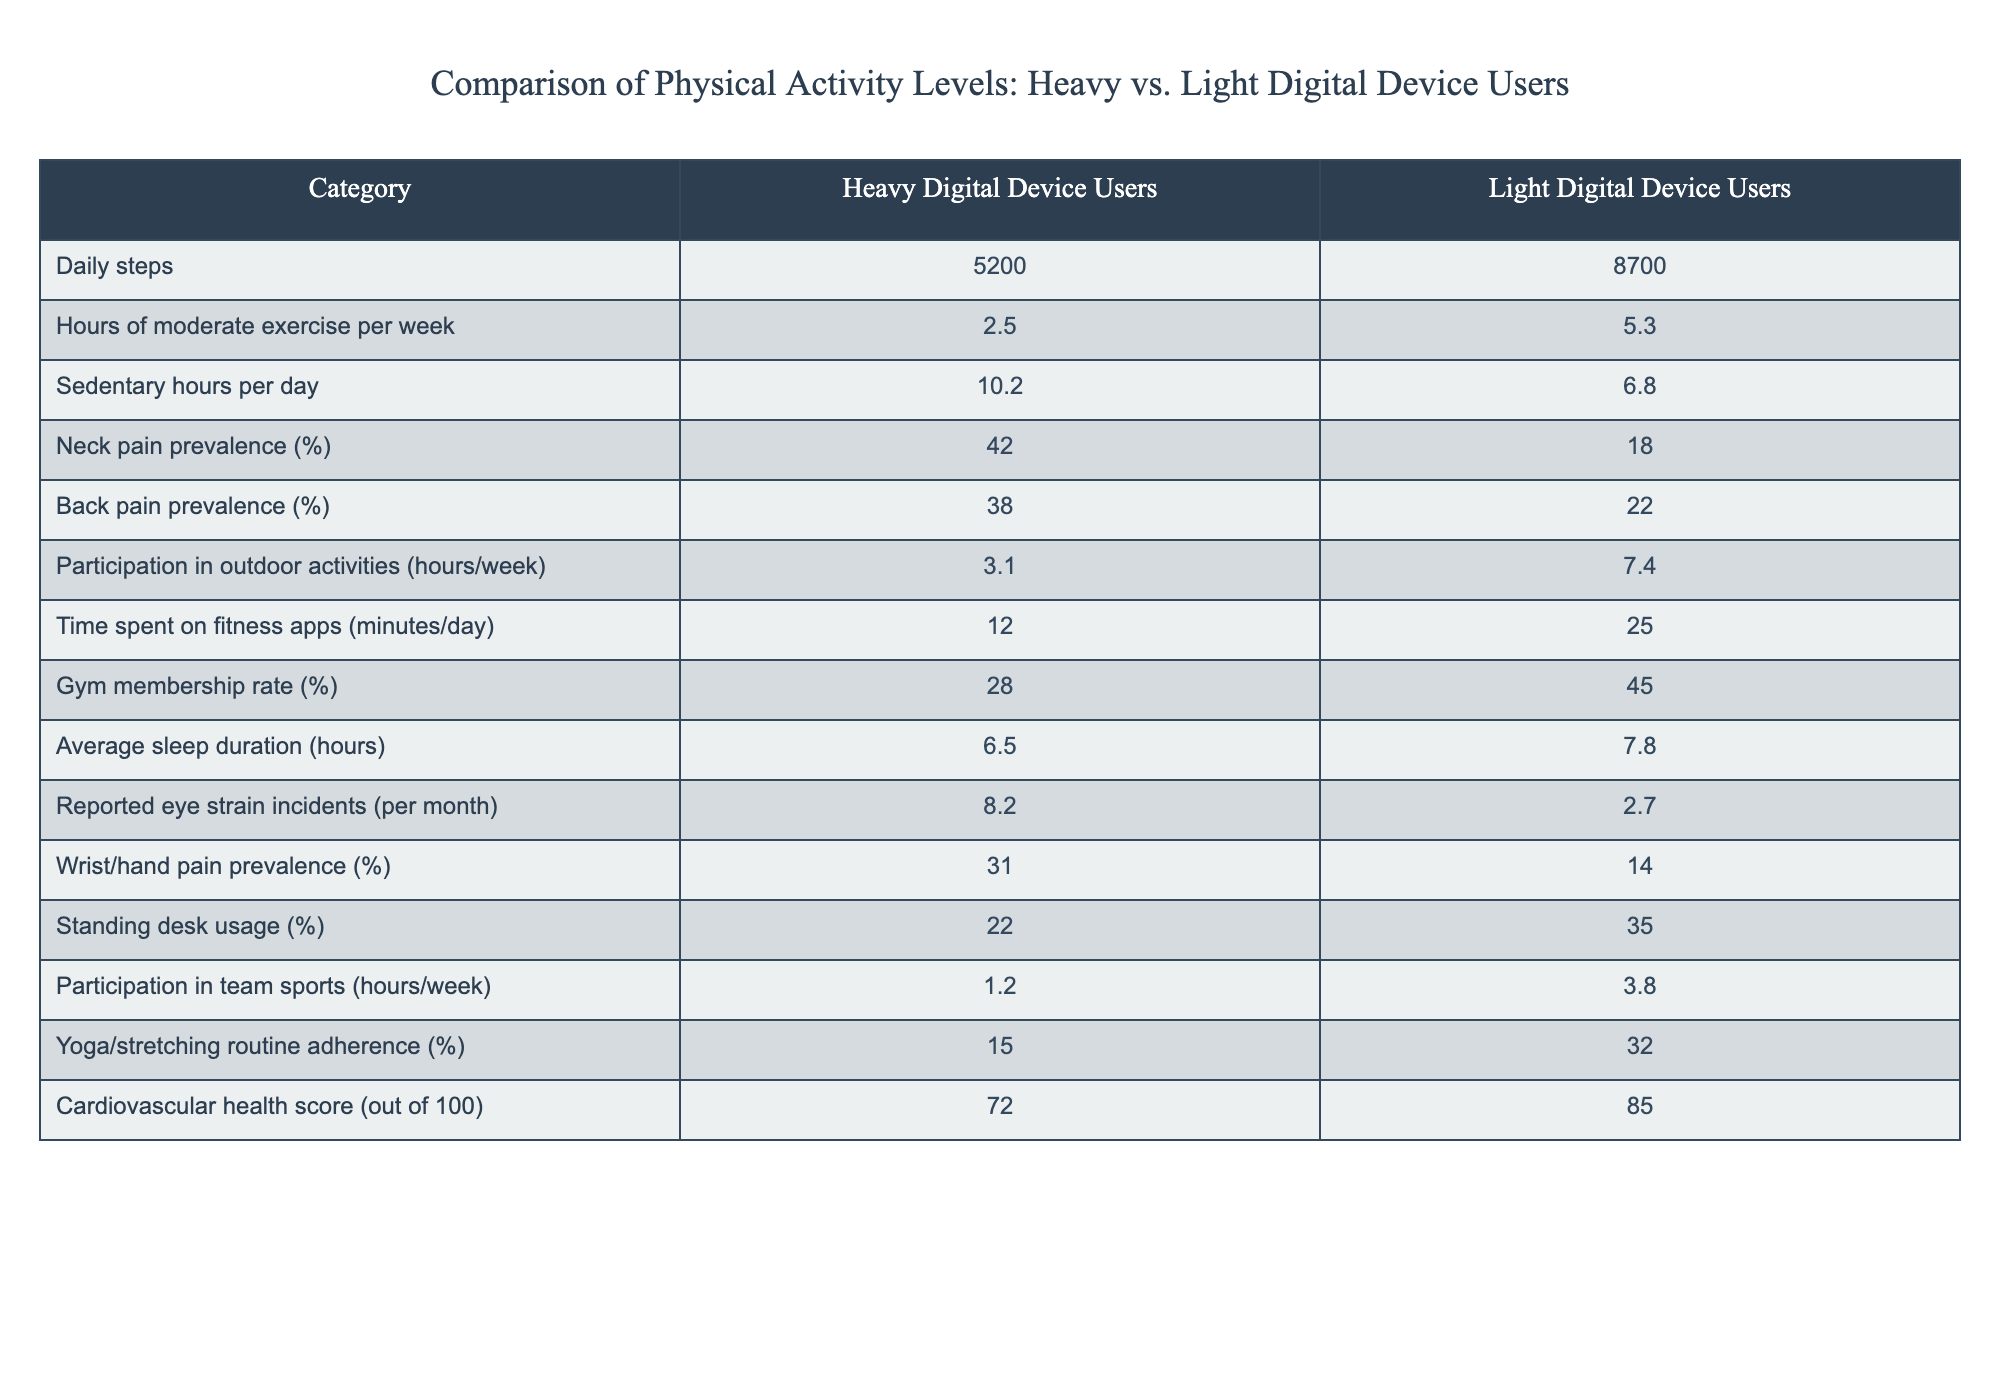What is the average daily steps for heavy digital device users? The table shows that heavy digital device users take 5200 steps per day. Since there is only one data point for heavy users, this is the average.
Answer: 5200 What is the percentage of neck pain prevalence among light digital device users? Referring to the table, the neck pain prevalence for light digital device users is stated as 18%.
Answer: 18% What is the difference in average daily steps between heavy and light digital device users? Heavy digital device users take 5200 steps daily, while light users take 8700 steps. The difference is calculated as 8700 - 5200 = 3500.
Answer: 3500 Is the prevalence of back pain higher among heavy digital device users compared to light users? The prevalence for heavy digital device users is 38%, while for light users it is 22%. Since 38% is greater than 22%, the statement is true.
Answer: Yes What percentage of light digital device users participate in a yoga/stretching routine? According to the table, 32% of light digital device users adhere to a yoga/stretching routine.
Answer: 32% How many more hours of moderate exercise are performed by light digital device users compared to heavy users per week? Light digital device users have 5.3 hours of moderate exercise per week, while heavy users have 2.5 hours. The difference is 5.3 - 2.5 = 2.8 hours.
Answer: 2.8 hours What is the average sleep duration difference between heavy and light digital device users? The average sleep duration for heavy users is 6.5 hours, while for light users, it is 7.8 hours. The difference is calculated as 7.8 - 6.5 = 1.3 hours.
Answer: 1.3 hours Do heavy digital device users spend more time on fitness apps than light users? Heavy users spend 12 minutes per day on fitness apps, while light users spend 25 minutes. Since 12 is less than 25, the statement is false.
Answer: No Is it accurate that light digital device users participate in more outdoor activities than heavy users? The table shows outdoor activities are 7.4 hours for light users and 3.1 hours for heavy users. Since 7.4 is greater than 3.1, this statement is true.
Answer: Yes 